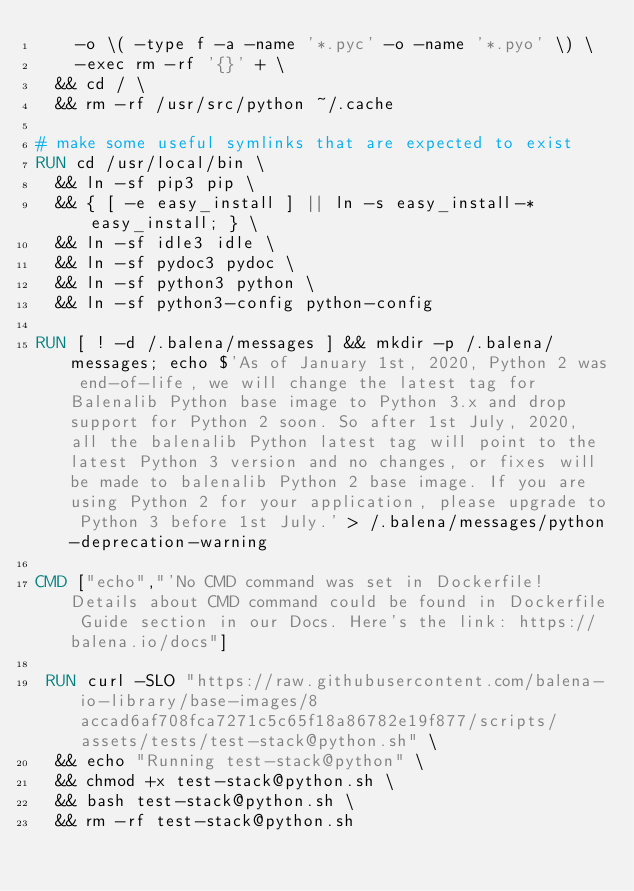<code> <loc_0><loc_0><loc_500><loc_500><_Dockerfile_>		-o \( -type f -a -name '*.pyc' -o -name '*.pyo' \) \
		-exec rm -rf '{}' + \
	&& cd / \
	&& rm -rf /usr/src/python ~/.cache

# make some useful symlinks that are expected to exist
RUN cd /usr/local/bin \
	&& ln -sf pip3 pip \
	&& { [ -e easy_install ] || ln -s easy_install-* easy_install; } \
	&& ln -sf idle3 idle \
	&& ln -sf pydoc3 pydoc \
	&& ln -sf python3 python \
	&& ln -sf python3-config python-config

RUN [ ! -d /.balena/messages ] && mkdir -p /.balena/messages; echo $'As of January 1st, 2020, Python 2 was end-of-life, we will change the latest tag for Balenalib Python base image to Python 3.x and drop support for Python 2 soon. So after 1st July, 2020, all the balenalib Python latest tag will point to the latest Python 3 version and no changes, or fixes will be made to balenalib Python 2 base image. If you are using Python 2 for your application, please upgrade to Python 3 before 1st July.' > /.balena/messages/python-deprecation-warning

CMD ["echo","'No CMD command was set in Dockerfile! Details about CMD command could be found in Dockerfile Guide section in our Docs. Here's the link: https://balena.io/docs"]

 RUN curl -SLO "https://raw.githubusercontent.com/balena-io-library/base-images/8accad6af708fca7271c5c65f18a86782e19f877/scripts/assets/tests/test-stack@python.sh" \
  && echo "Running test-stack@python" \
  && chmod +x test-stack@python.sh \
  && bash test-stack@python.sh \
  && rm -rf test-stack@python.sh 
</code> 